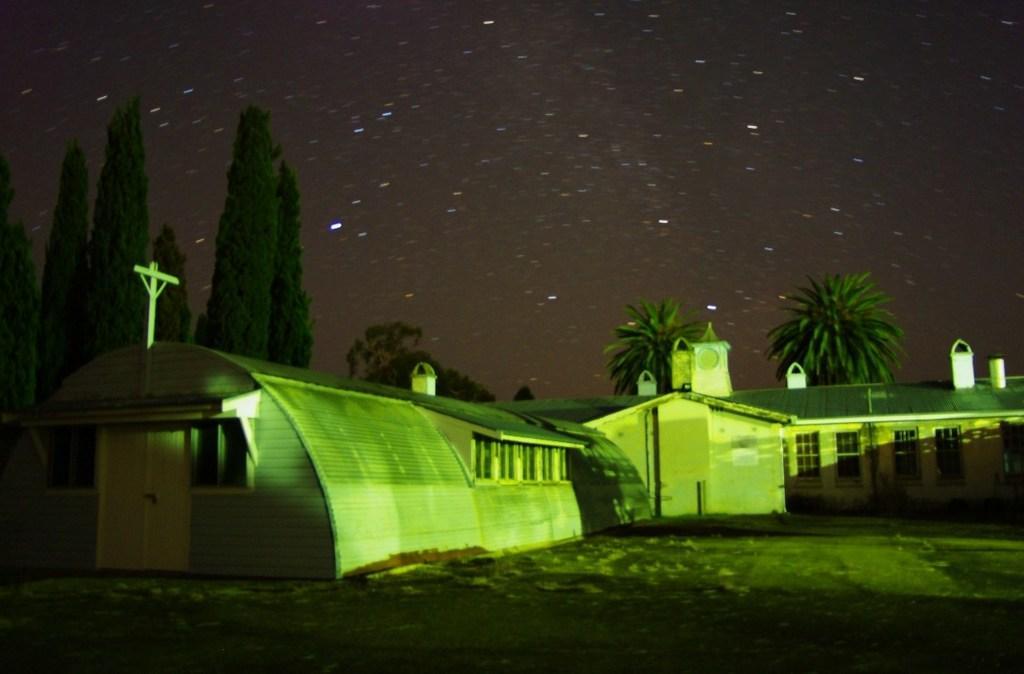In one or two sentences, can you explain what this image depicts? This image is taken during the night time where there are buildings at the bottom. In the background there are trees. At the top there is the sky with the stars. At the bottom there is ground. 